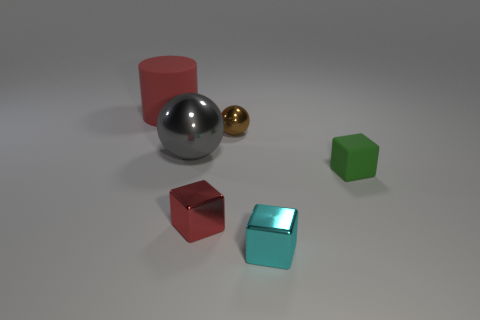Add 1 shiny things. How many objects exist? 7 Subtract all balls. How many objects are left? 4 Add 4 brown balls. How many brown balls are left? 5 Add 5 small metallic blocks. How many small metallic blocks exist? 7 Subtract 0 purple cylinders. How many objects are left? 6 Subtract all red cylinders. Subtract all cyan metallic blocks. How many objects are left? 4 